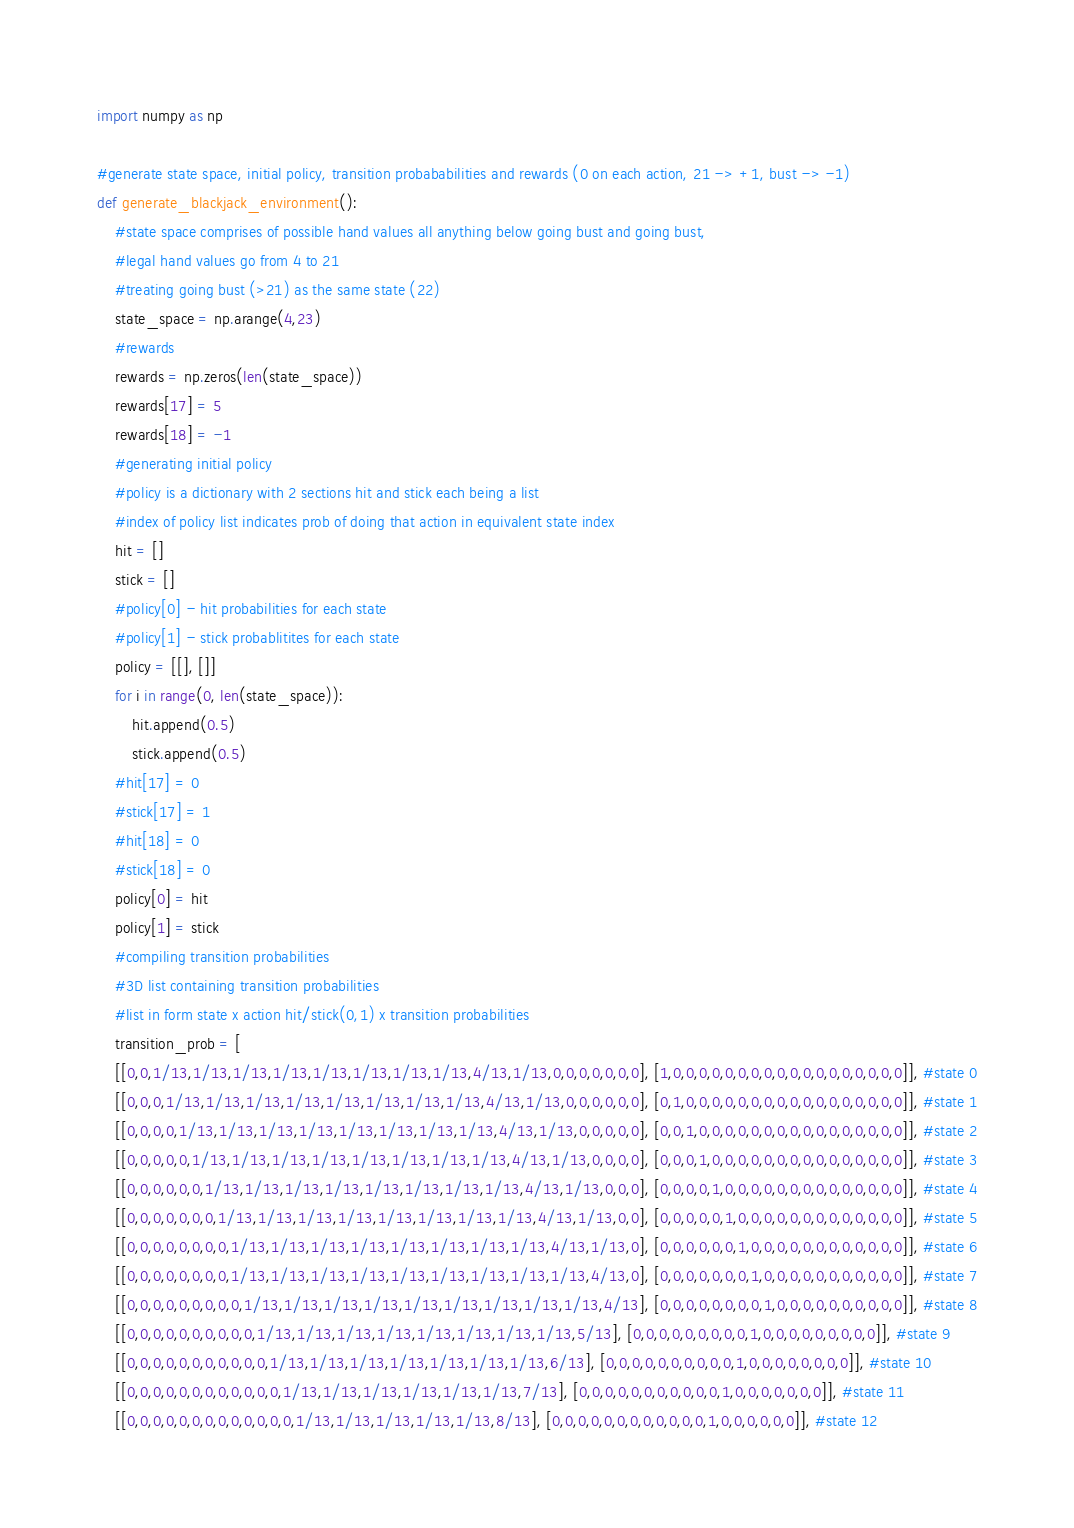Convert code to text. <code><loc_0><loc_0><loc_500><loc_500><_Python_>import numpy as np 

#generate state space, initial policy, transition probababilities and rewards (0 on each action, 21 -> +1, bust -> -1)
def generate_blackjack_environment():
    #state space comprises of possible hand values all anything below going bust and going bust,
    #legal hand values go from 4 to 21
    #treating going bust (>21) as the same state (22)
    state_space = np.arange(4,23)
    #rewards
    rewards = np.zeros(len(state_space))
    rewards[17] = 5
    rewards[18] = -1
    #generating initial policy
    #policy is a dictionary with 2 sections hit and stick each being a list
    #index of policy list indicates prob of doing that action in equivalent state index
    hit = []
    stick = []
    #policy[0] - hit probabilities for each state
    #policy[1] - stick probablitites for each state
    policy = [[], []]
    for i in range(0, len(state_space)):
        hit.append(0.5)
        stick.append(0.5)
    #hit[17] = 0
    #stick[17] = 1
    #hit[18] = 0
    #stick[18] = 0  
    policy[0] = hit
    policy[1] = stick
    #compiling transition probabilities
    #3D list containing transition probabilities
    #list in form state x action hit/stick(0,1) x transition probabilities
    transition_prob = [
    [[0,0,1/13,1/13,1/13,1/13,1/13,1/13,1/13,1/13,4/13,1/13,0,0,0,0,0,0,0], [1,0,0,0,0,0,0,0,0,0,0,0,0,0,0,0,0,0,0]], #state 0
    [[0,0,0,1/13,1/13,1/13,1/13,1/13,1/13,1/13,1/13,4/13,1/13,0,0,0,0,0,0], [0,1,0,0,0,0,0,0,0,0,0,0,0,0,0,0,0,0,0]], #state 1
    [[0,0,0,0,1/13,1/13,1/13,1/13,1/13,1/13,1/13,1/13,4/13,1/13,0,0,0,0,0], [0,0,1,0,0,0,0,0,0,0,0,0,0,0,0,0,0,0,0]], #state 2
    [[0,0,0,0,0,1/13,1/13,1/13,1/13,1/13,1/13,1/13,1/13,4/13,1/13,0,0,0,0], [0,0,0,1,0,0,0,0,0,0,0,0,0,0,0,0,0,0,0]], #state 3
    [[0,0,0,0,0,0,1/13,1/13,1/13,1/13,1/13,1/13,1/13,1/13,4/13,1/13,0,0,0], [0,0,0,0,1,0,0,0,0,0,0,0,0,0,0,0,0,0,0]], #state 4
    [[0,0,0,0,0,0,0,1/13,1/13,1/13,1/13,1/13,1/13,1/13,1/13,4/13,1/13,0,0], [0,0,0,0,0,1,0,0,0,0,0,0,0,0,0,0,0,0,0]], #state 5
    [[0,0,0,0,0,0,0,0,1/13,1/13,1/13,1/13,1/13,1/13,1/13,1/13,4/13,1/13,0], [0,0,0,0,0,0,1,0,0,0,0,0,0,0,0,0,0,0,0]], #state 6
    [[0,0,0,0,0,0,0,0,1/13,1/13,1/13,1/13,1/13,1/13,1/13,1/13,1/13,4/13,0], [0,0,0,0,0,0,0,1,0,0,0,0,0,0,0,0,0,0,0]], #state 7
    [[0,0,0,0,0,0,0,0,0,1/13,1/13,1/13,1/13,1/13,1/13,1/13,1/13,1/13,4/13], [0,0,0,0,0,0,0,0,1,0,0,0,0,0,0,0,0,0,0]], #state 8
    [[0,0,0,0,0,0,0,0,0,0,1/13,1/13,1/13,1/13,1/13,1/13,1/13,1/13,5/13], [0,0,0,0,0,0,0,0,0,1,0,0,0,0,0,0,0,0,0]], #state 9
    [[0,0,0,0,0,0,0,0,0,0,0,1/13,1/13,1/13,1/13,1/13,1/13,1/13,6/13], [0,0,0,0,0,0,0,0,0,0,1,0,0,0,0,0,0,0,0]], #state 10
    [[0,0,0,0,0,0,0,0,0,0,0,0,1/13,1/13,1/13,1/13,1/13,1/13,7/13], [0,0,0,0,0,0,0,0,0,0,0,1,0,0,0,0,0,0,0]], #state 11
    [[0,0,0,0,0,0,0,0,0,0,0,0,0,1/13,1/13,1/13,1/13,1/13,8/13], [0,0,0,0,0,0,0,0,0,0,0,0,1,0,0,0,0,0,0]], #state 12</code> 